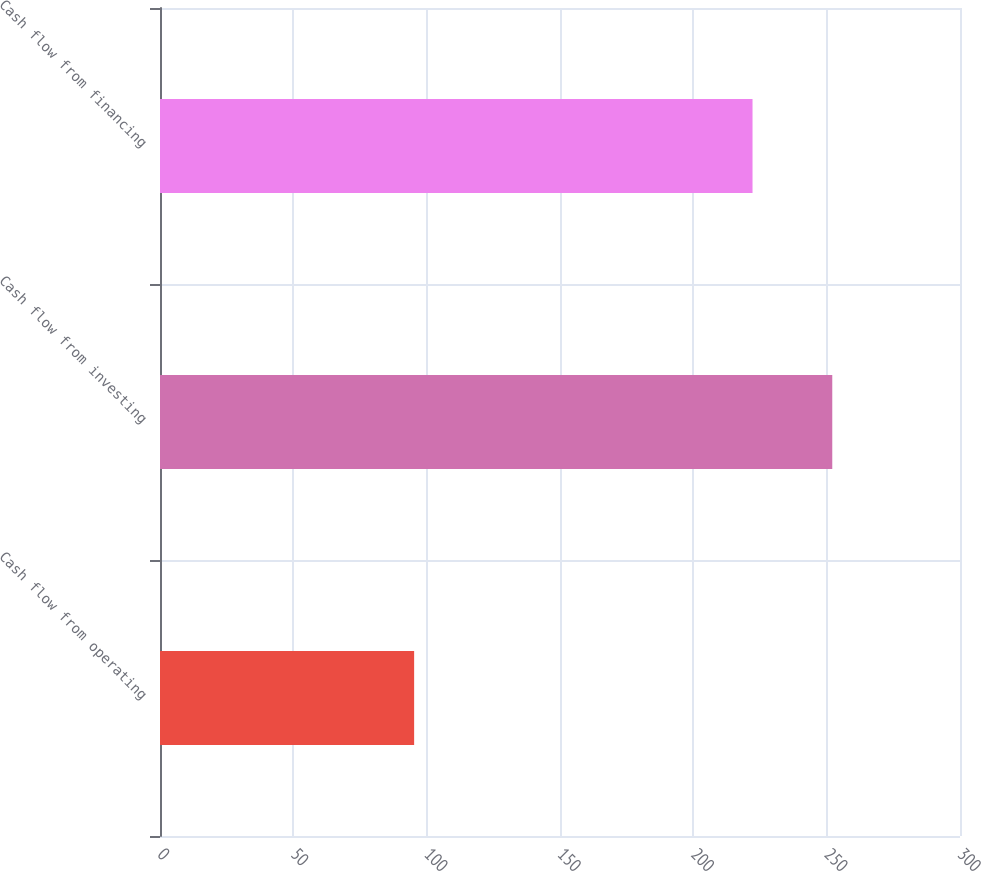Convert chart to OTSL. <chart><loc_0><loc_0><loc_500><loc_500><bar_chart><fcel>Cash flow from operating<fcel>Cash flow from investing<fcel>Cash flow from financing<nl><fcel>95.3<fcel>252.1<fcel>222.2<nl></chart> 